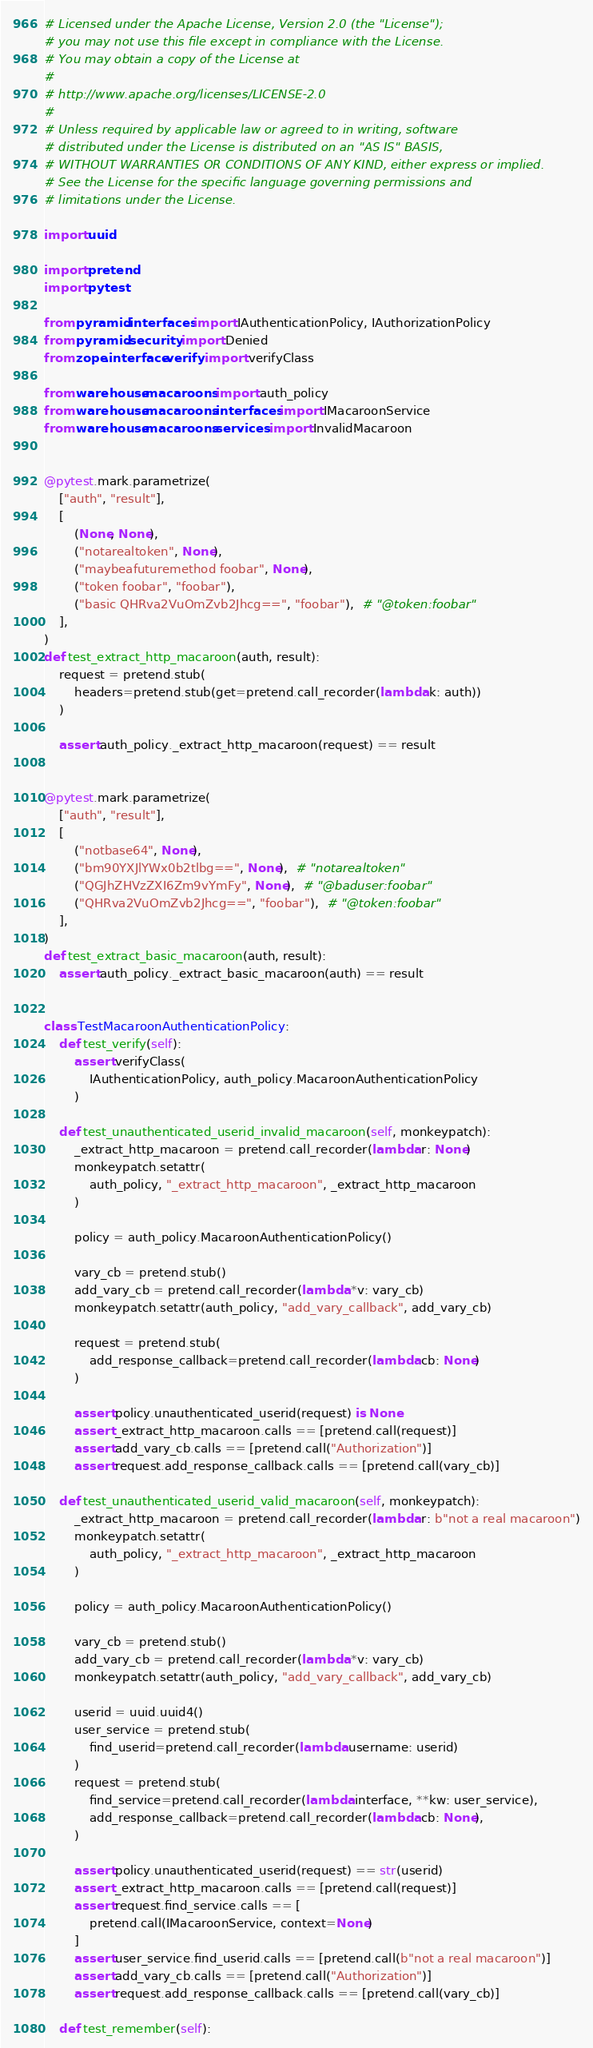Convert code to text. <code><loc_0><loc_0><loc_500><loc_500><_Python_># Licensed under the Apache License, Version 2.0 (the "License");
# you may not use this file except in compliance with the License.
# You may obtain a copy of the License at
#
# http://www.apache.org/licenses/LICENSE-2.0
#
# Unless required by applicable law or agreed to in writing, software
# distributed under the License is distributed on an "AS IS" BASIS,
# WITHOUT WARRANTIES OR CONDITIONS OF ANY KIND, either express or implied.
# See the License for the specific language governing permissions and
# limitations under the License.

import uuid

import pretend
import pytest

from pyramid.interfaces import IAuthenticationPolicy, IAuthorizationPolicy
from pyramid.security import Denied
from zope.interface.verify import verifyClass

from warehouse.macaroons import auth_policy
from warehouse.macaroons.interfaces import IMacaroonService
from warehouse.macaroons.services import InvalidMacaroon


@pytest.mark.parametrize(
    ["auth", "result"],
    [
        (None, None),
        ("notarealtoken", None),
        ("maybeafuturemethod foobar", None),
        ("token foobar", "foobar"),
        ("basic QHRva2VuOmZvb2Jhcg==", "foobar"),  # "@token:foobar"
    ],
)
def test_extract_http_macaroon(auth, result):
    request = pretend.stub(
        headers=pretend.stub(get=pretend.call_recorder(lambda k: auth))
    )

    assert auth_policy._extract_http_macaroon(request) == result


@pytest.mark.parametrize(
    ["auth", "result"],
    [
        ("notbase64", None),
        ("bm90YXJlYWx0b2tlbg==", None),  # "notarealtoken"
        ("QGJhZHVzZXI6Zm9vYmFy", None),  # "@baduser:foobar"
        ("QHRva2VuOmZvb2Jhcg==", "foobar"),  # "@token:foobar"
    ],
)
def test_extract_basic_macaroon(auth, result):
    assert auth_policy._extract_basic_macaroon(auth) == result


class TestMacaroonAuthenticationPolicy:
    def test_verify(self):
        assert verifyClass(
            IAuthenticationPolicy, auth_policy.MacaroonAuthenticationPolicy
        )

    def test_unauthenticated_userid_invalid_macaroon(self, monkeypatch):
        _extract_http_macaroon = pretend.call_recorder(lambda r: None)
        monkeypatch.setattr(
            auth_policy, "_extract_http_macaroon", _extract_http_macaroon
        )

        policy = auth_policy.MacaroonAuthenticationPolicy()

        vary_cb = pretend.stub()
        add_vary_cb = pretend.call_recorder(lambda *v: vary_cb)
        monkeypatch.setattr(auth_policy, "add_vary_callback", add_vary_cb)

        request = pretend.stub(
            add_response_callback=pretend.call_recorder(lambda cb: None)
        )

        assert policy.unauthenticated_userid(request) is None
        assert _extract_http_macaroon.calls == [pretend.call(request)]
        assert add_vary_cb.calls == [pretend.call("Authorization")]
        assert request.add_response_callback.calls == [pretend.call(vary_cb)]

    def test_unauthenticated_userid_valid_macaroon(self, monkeypatch):
        _extract_http_macaroon = pretend.call_recorder(lambda r: b"not a real macaroon")
        monkeypatch.setattr(
            auth_policy, "_extract_http_macaroon", _extract_http_macaroon
        )

        policy = auth_policy.MacaroonAuthenticationPolicy()

        vary_cb = pretend.stub()
        add_vary_cb = pretend.call_recorder(lambda *v: vary_cb)
        monkeypatch.setattr(auth_policy, "add_vary_callback", add_vary_cb)

        userid = uuid.uuid4()
        user_service = pretend.stub(
            find_userid=pretend.call_recorder(lambda username: userid)
        )
        request = pretend.stub(
            find_service=pretend.call_recorder(lambda interface, **kw: user_service),
            add_response_callback=pretend.call_recorder(lambda cb: None),
        )

        assert policy.unauthenticated_userid(request) == str(userid)
        assert _extract_http_macaroon.calls == [pretend.call(request)]
        assert request.find_service.calls == [
            pretend.call(IMacaroonService, context=None)
        ]
        assert user_service.find_userid.calls == [pretend.call(b"not a real macaroon")]
        assert add_vary_cb.calls == [pretend.call("Authorization")]
        assert request.add_response_callback.calls == [pretend.call(vary_cb)]

    def test_remember(self):</code> 